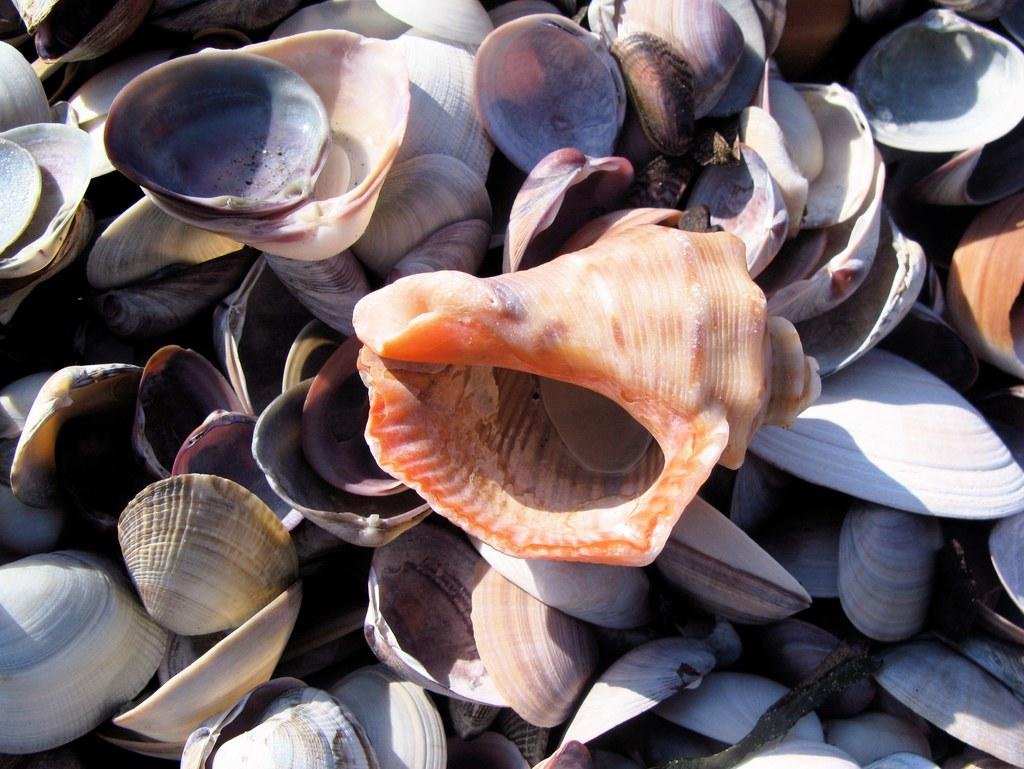What type of objects can be seen in the image? There are shells in the image. Can you describe the variety of shells in the image? The shells come in different types. What can be observed about the appearance of the shells? The shells have different colors. What time of day is it in the image? The image does not provide any information about the time of day. 